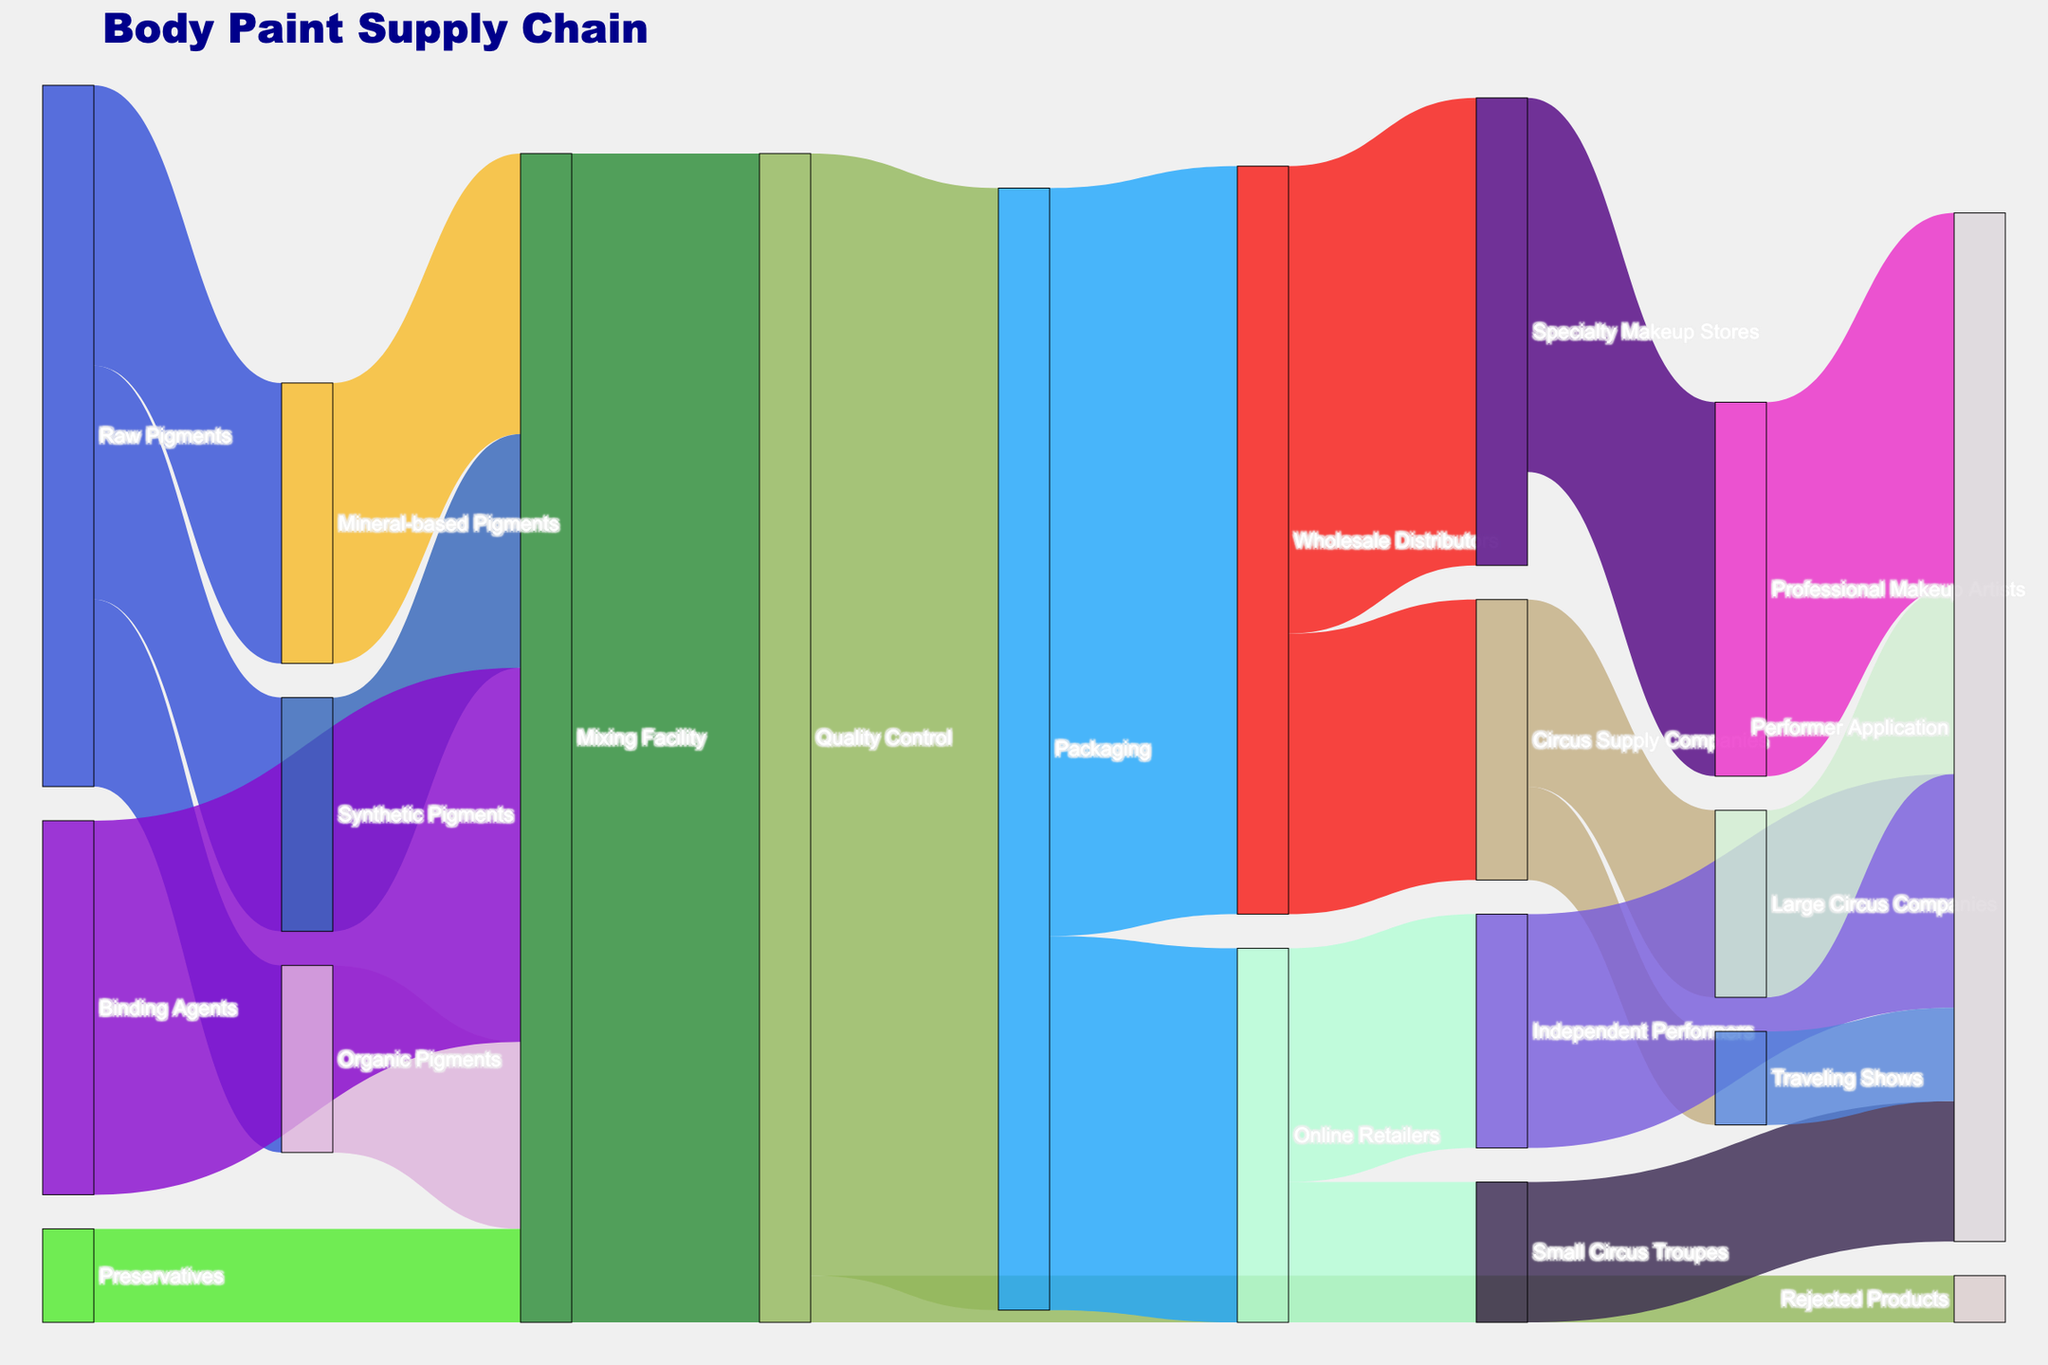Which node has the highest incoming flow value? Look at the node with the largest total value directed towards it. All flows reach "Mixing Facility" with a sum: 300 (Mineral-based Pigments) + 200 (Organic Pigments) + 250 (Synthetic Pigments) + 400 (Binding Agents) + 100 (Preservatives) = 1250
Answer: Mixing Facility Which node receives products from the "Packaging" node? Identify nodes connected to "Packaging" with outgoing flows: "Wholesale Distributors" and "Online Retailers" are directly connected.
Answer: Wholesale Distributors, Online Retailers How many products are tagged as "Rejected"? Look at the flow labeled "Rejected Products". It shows 50 units coming from "Quality Control".
Answer: 50 How many types of pigments are mixed in the "Mixing Facility"? Check the incoming nodes directed to "Mixing Facility": "Mineral-based Pigments", "Organic Pigments", and "Synthetic Pigments", totaling 3 types.
Answer: 3 What is the total value of products moving from "Packaging" to end users? Sum all flows from "Packaging" to end nodes (end products): 800 (Wholesale Distributors) + 400 (Online Retailers) = 1200
Answer: 1200 Which node has an equal split in its outgoing flow values? Look at the nodes with equal splits in their outgoing flows. "Traveling Shows" has 100 units going to "Performer Application".
Answer: Traveling Shows What's the difference in flow value between "Large Circus Companies" and "Small Circus Troupes"? Calculate the absolute difference: "Large Circus Companies" (200) - "Small Circus Troupes" (150) = 50
Answer: 50 Which node serves as a middle point before products reach performers? Identify an intermediate node before the final "Performer Application" node: "Circus Supply Companies" and "Professional Makeup Artists" act as intermediaries.
Answer: Circus Supply Companies, Professional Makeup Artists What's the combined value of products ending up with "Independent Performers" and "Small Circus Troupes"? Add the flows ending at these nodes: 250 (Independent Performers) + 150 (Small Circus Troupes) = 400
Answer: 400 Which group receives the largest number of finished products? Examine the node with the largest final flow value directed towards "Professional Makeup Artists" with 400 units.
Answer: Professional Makeup Artists 